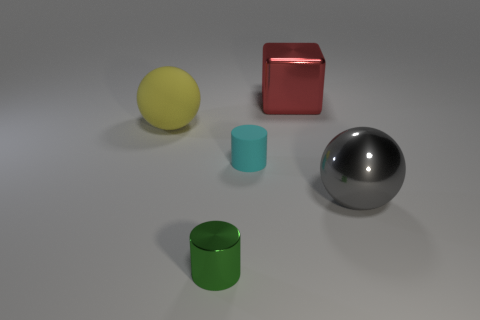There is a yellow sphere that is the same size as the gray shiny object; what is it made of?
Your answer should be very brief. Rubber. What number of other objects are the same material as the tiny cyan cylinder?
Keep it short and to the point. 1. There is a yellow thing that is on the left side of the large metallic cube; does it have the same shape as the big object in front of the rubber cylinder?
Your answer should be compact. Yes. The cylinder that is behind the small metallic cylinder that is on the right side of the large ball that is left of the shiny ball is what color?
Offer a terse response. Cyan. Are there fewer red metal cubes than metallic objects?
Give a very brief answer. Yes. What color is the object that is in front of the rubber cylinder and to the left of the big red metal block?
Ensure brevity in your answer.  Green. There is a cyan object that is the same shape as the small green metal object; what material is it?
Your answer should be compact. Rubber. Are there more small gray shiny cylinders than tiny green shiny cylinders?
Provide a short and direct response. No. There is a thing that is in front of the small cyan cylinder and on the left side of the tiny cyan rubber cylinder; what size is it?
Your answer should be compact. Small. What is the shape of the red thing?
Provide a succinct answer. Cube. 